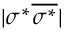<formula> <loc_0><loc_0><loc_500><loc_500>| \sigma ^ { * } \overline { { \sigma ^ { * } } } |</formula> 